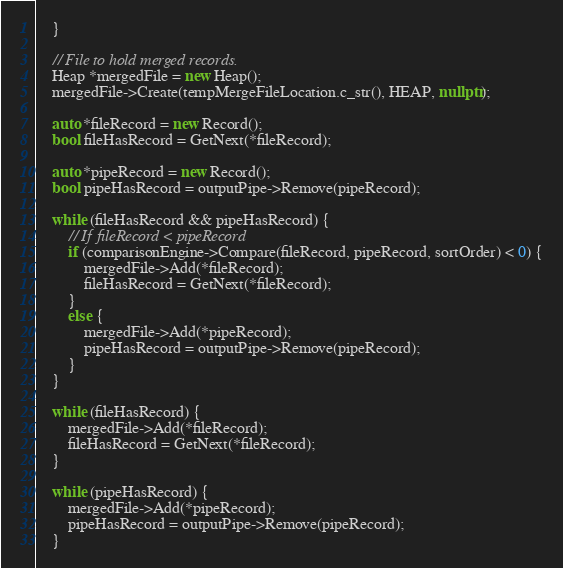<code> <loc_0><loc_0><loc_500><loc_500><_C++_>    }

    // File to hold merged records.
    Heap *mergedFile = new Heap();
    mergedFile->Create(tempMergeFileLocation.c_str(), HEAP, nullptr);

    auto *fileRecord = new Record();
    bool fileHasRecord = GetNext(*fileRecord);

    auto *pipeRecord = new Record();
    bool pipeHasRecord = outputPipe->Remove(pipeRecord);

    while (fileHasRecord && pipeHasRecord) {
        // If fileRecord < pipeRecord
        if (comparisonEngine->Compare(fileRecord, pipeRecord, sortOrder) < 0) {
            mergedFile->Add(*fileRecord);
            fileHasRecord = GetNext(*fileRecord);
        }
        else {
            mergedFile->Add(*pipeRecord);
            pipeHasRecord = outputPipe->Remove(pipeRecord);
        }
    }

    while (fileHasRecord) {
        mergedFile->Add(*fileRecord);
        fileHasRecord = GetNext(*fileRecord);
    }

    while (pipeHasRecord) {
        mergedFile->Add(*pipeRecord);
        pipeHasRecord = outputPipe->Remove(pipeRecord);
    }
</code> 